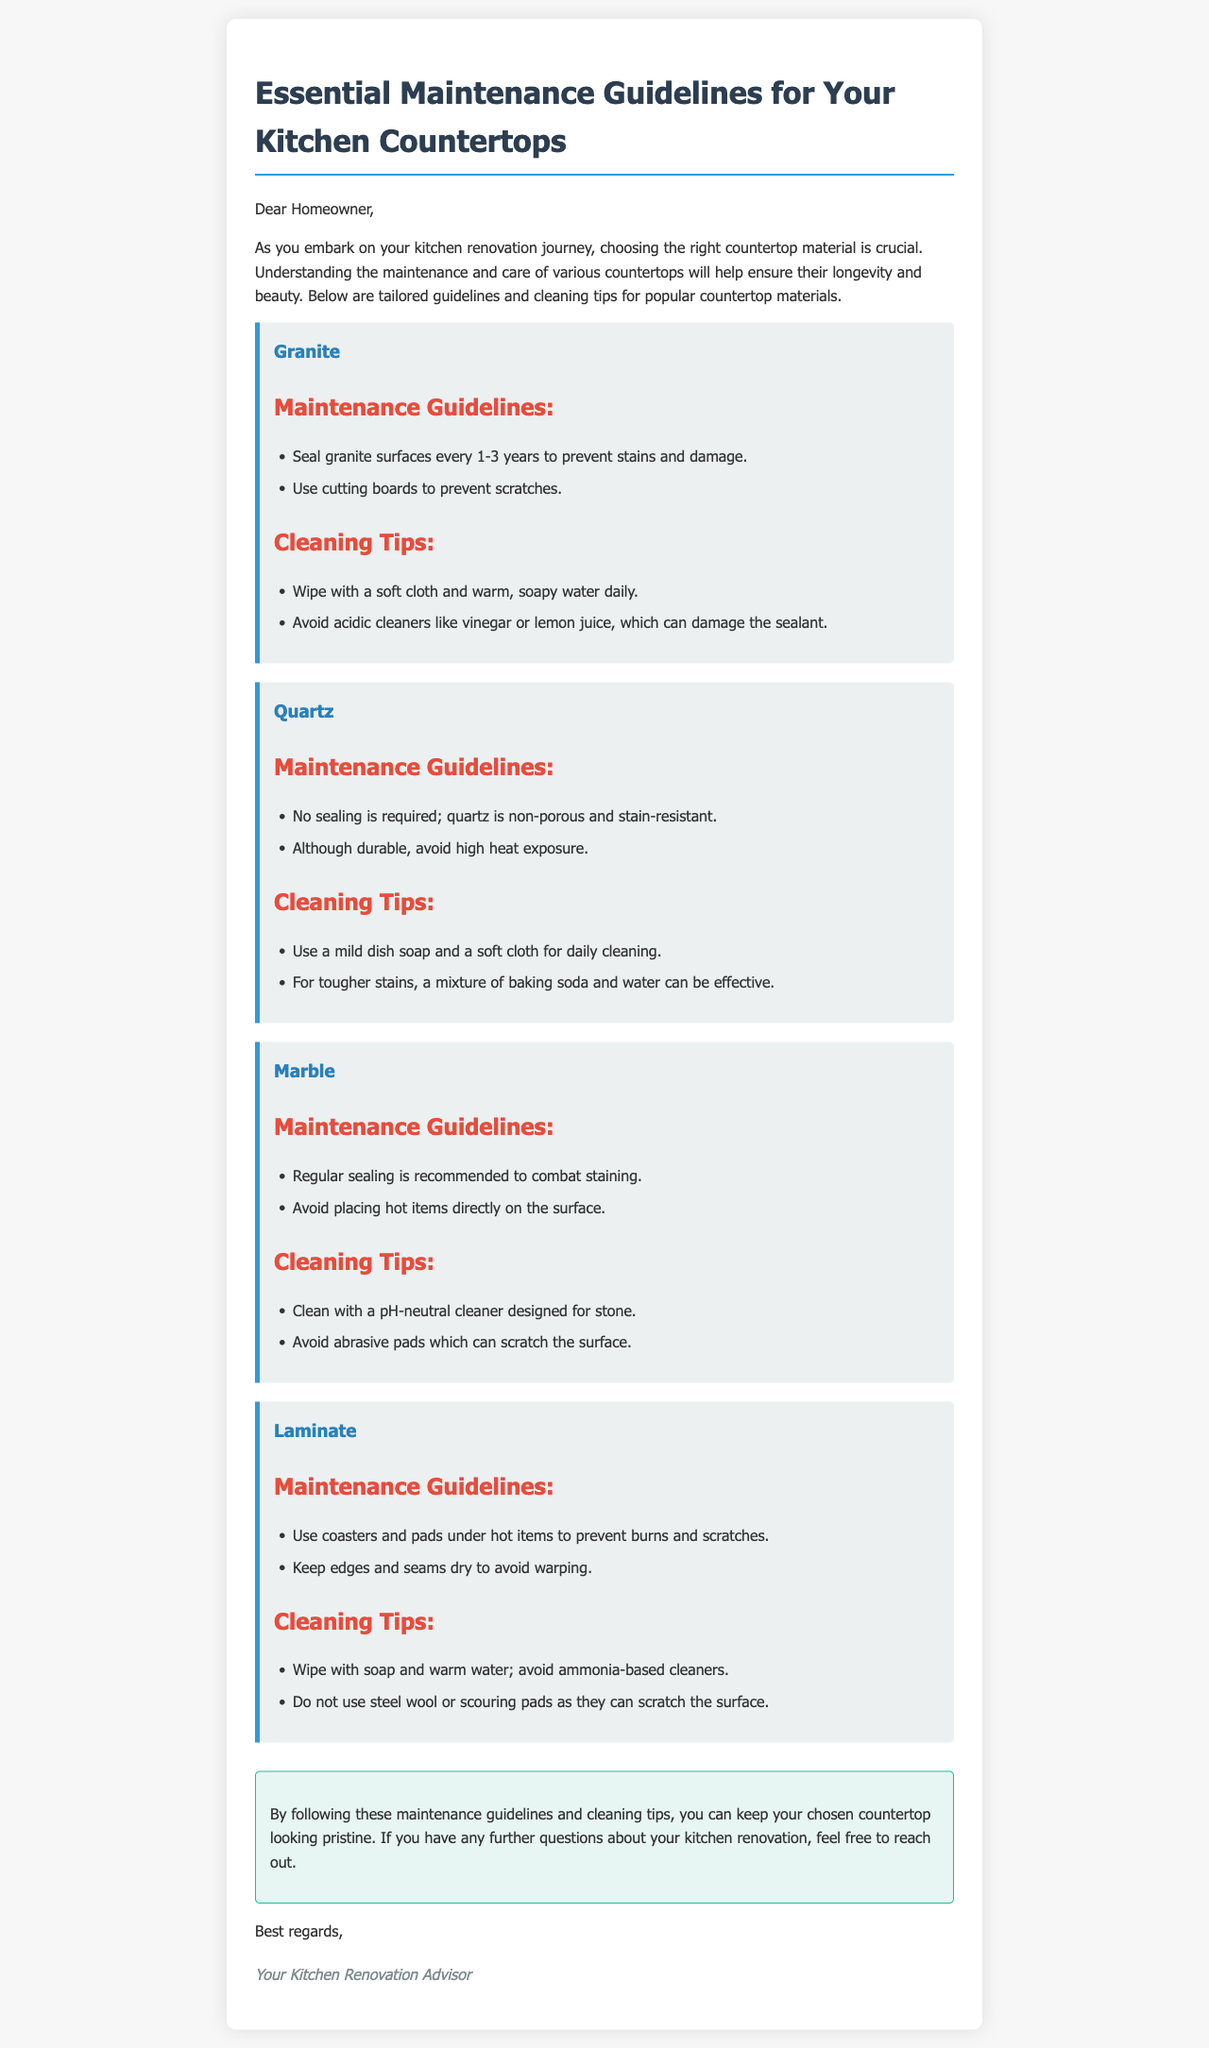what is the recommended sealing frequency for granite? The document states that granite surfaces should be sealed every 1-3 years to prevent stains and damage.
Answer: every 1-3 years what kind of cleaner should be avoided for granite? The document indicates that acidic cleaners like vinegar or lemon juice can damage the sealant of granite.
Answer: acidic cleaners is sealing required for quartz countertops? The document clearly states that no sealing is required for quartz as it is non-porous and stain-resistant.
Answer: no what can be used to address tougher stains on quartz? The document mentions that a mixture of baking soda and water can be effective for tougher stains on quartz.
Answer: baking soda and water what is recommended to avoid with laminate surfaces? The document advises using coasters and pads under hot items to prevent burns and scratches on laminate surfaces.
Answer: coasters and pads what type of cleaner is recommended for marble countertops? The document specifies that a pH-neutral cleaner designed for stone should be used for marble countertops.
Answer: pH-neutral cleaner what should be kept dry to avoid warping in laminate? The document notes that edges and seams of laminate countertops should be kept dry to prevent warping.
Answer: edges and seams what is the purpose of the conclusion in the document? The conclusion serves to summarize the importance of following maintenance guidelines and encourages further questions about kitchen renovation.
Answer: summarize importance how are granite surfaces advised to be wiped daily? The document states that granite surfaces should be wiped with a soft cloth and warm, soapy water daily.
Answer: soft cloth and warm, soapy water 